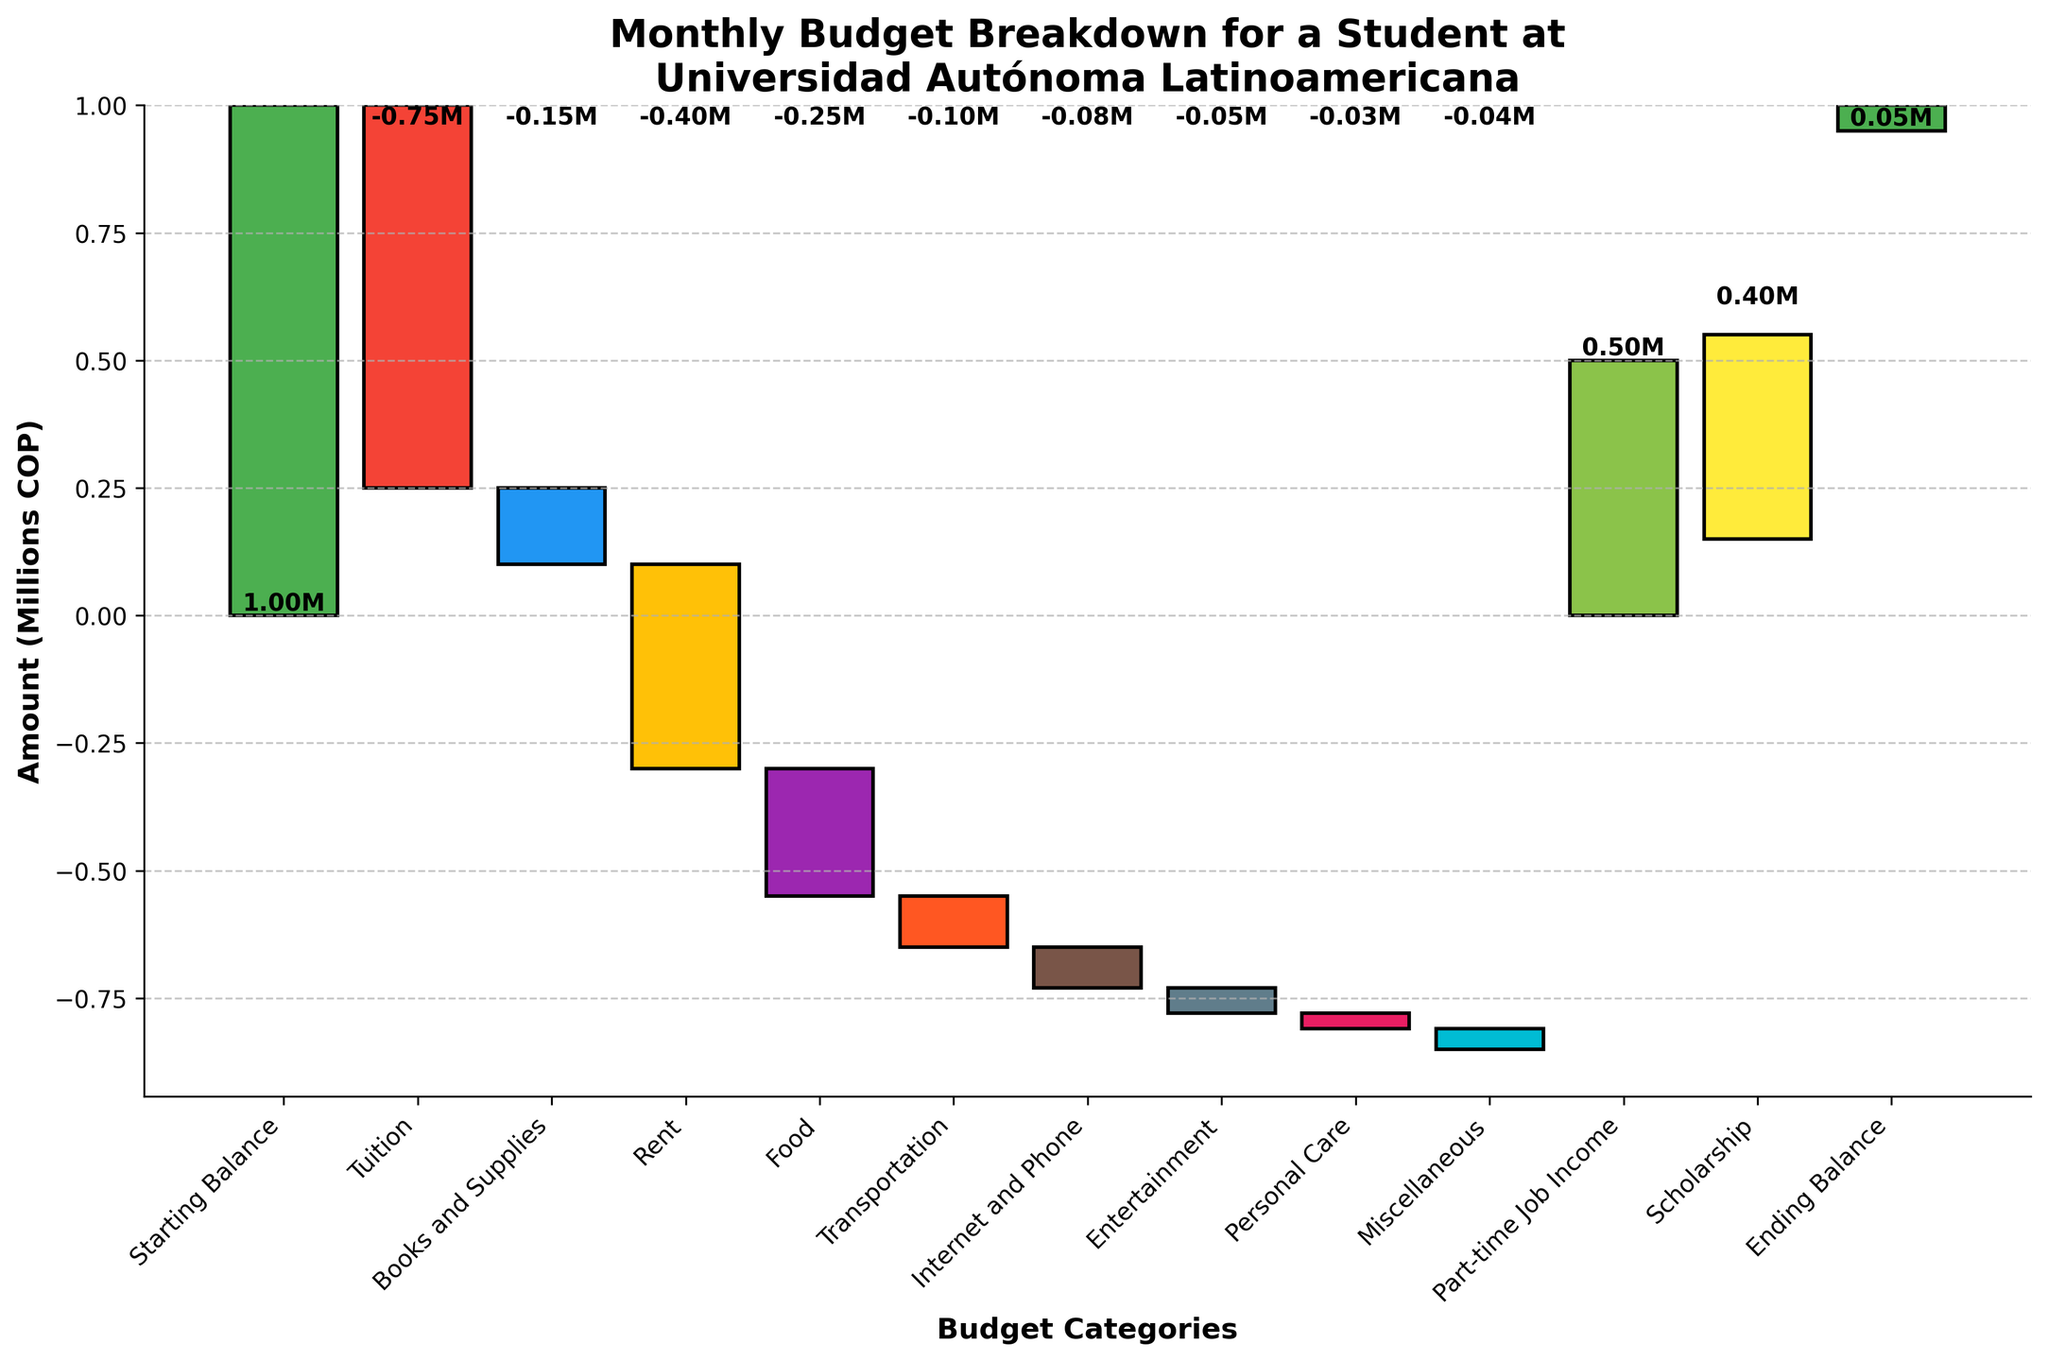What is the starting balance for the student? The starting balance is the first category listed on the chart. It shows the total amount available at the beginning of the month.
Answer: 1,000,000 COP Which category has the highest expense? The tallest bar in red below the zero line represents the highest expense. Tuition has the highest expense as the bar for "Tuition" is the longest downward bar.
Answer: Tuition What's the sum of all expenses except Tuition? Add all the negative amounts except for Tuition: -150,000 (Books and Supplies) - 400,000 (Rent) - 250,000 (Food) - 100,000 (Transportation) - 80,000 (Internet and Phone) - 50,000 (Entertainment) - 30,000 (Personal Care) - 40,000 (Miscellaneous). So, the total sum is -1,100,000 COP.
Answer: -1,100,000 COP What is the total income from all sources? Add the positive income amounts given: 500,000 (Part-time Job Income) + 400,000 (Scholarship), resulting in a total income of 900,000 COP.
Answer: 900,000 COP What is the ending balance for the student? The ending balance is the last category listed on the chart. This value represents the amount left at the end of the month.
Answer: 50,000 COP Which category has the smallest impact on the budget? The smallest bar represents the smallest impact. The "Personal Care" category has the shortest bar.
Answer: Personal Care How much more is spent on rent compared to food? The amounts for Rent and Food are shown as -400,000 and -250,000, respectively. The difference is -400,000 - (-250,000) = -150,000 COP.
Answer: 150,000 COP Which has a greater impact on the budget: Part-time Job Income or Rent? Part-time Job Income is a positive amount of 500,000 COP while Rent is a negative amount of -400,000 COP. Comparing their absolute values, 500,000 > 400,000.
Answer: Part-time Job Income If the student didn’t receive the scholarship, what would be the ending balance? Without the scholarship, subtract 400,000 COP from the ending balance of 50,000 COP. 50,000 - 400,000 = -350,000 COP (a deficit).
Answer: -350,000 COP How much more is the expense on Books and Supplies compared to the Internet and Phone? The amounts are -150,000 for Books and Supplies and -80,000 for Internet and Phone. The difference is -150,000 - (-80,000) = -70,000 COP.
Answer: 70,000 COP 